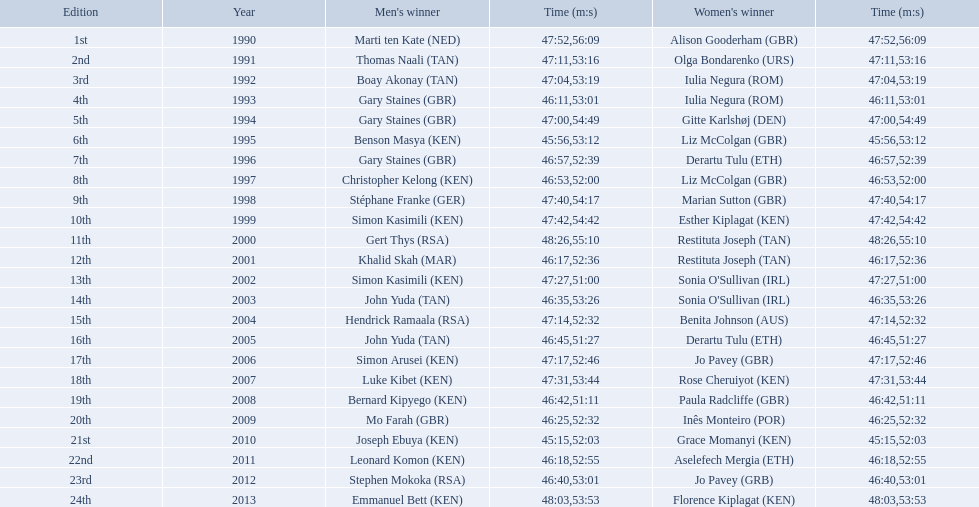Where any women faster than any men? No. 